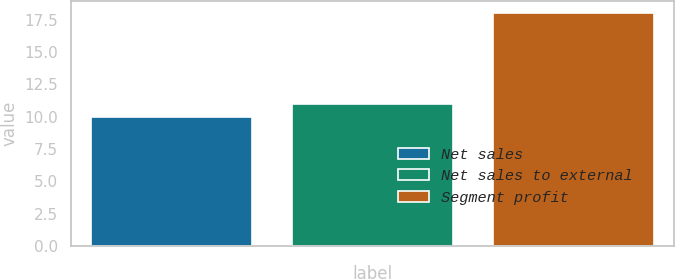Convert chart. <chart><loc_0><loc_0><loc_500><loc_500><bar_chart><fcel>Net sales<fcel>Net sales to external<fcel>Segment profit<nl><fcel>10<fcel>11<fcel>18<nl></chart> 